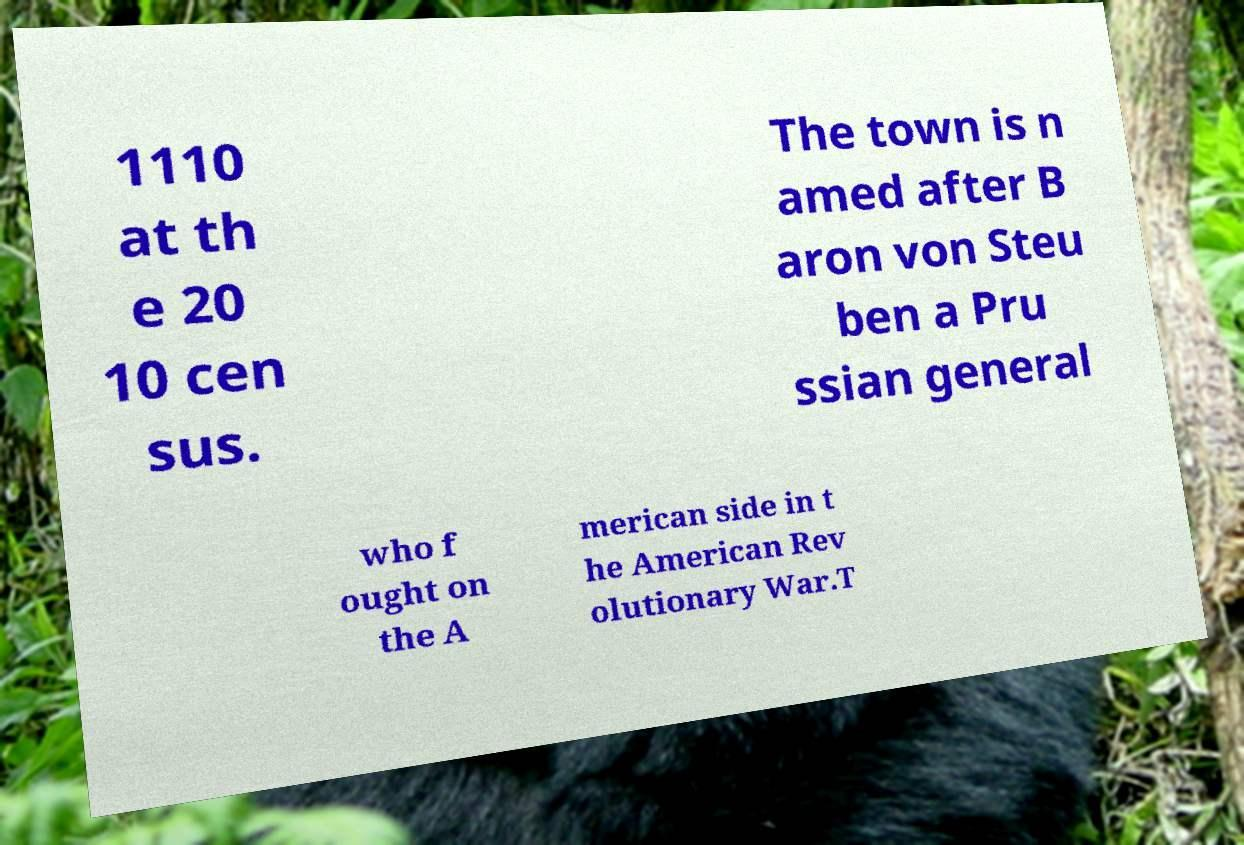I need the written content from this picture converted into text. Can you do that? 1110 at th e 20 10 cen sus. The town is n amed after B aron von Steu ben a Pru ssian general who f ought on the A merican side in t he American Rev olutionary War.T 